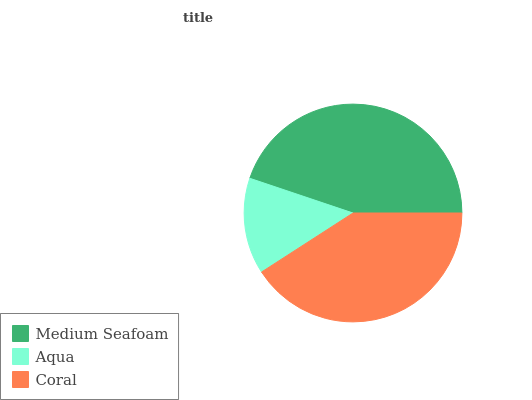Is Aqua the minimum?
Answer yes or no. Yes. Is Medium Seafoam the maximum?
Answer yes or no. Yes. Is Coral the minimum?
Answer yes or no. No. Is Coral the maximum?
Answer yes or no. No. Is Coral greater than Aqua?
Answer yes or no. Yes. Is Aqua less than Coral?
Answer yes or no. Yes. Is Aqua greater than Coral?
Answer yes or no. No. Is Coral less than Aqua?
Answer yes or no. No. Is Coral the high median?
Answer yes or no. Yes. Is Coral the low median?
Answer yes or no. Yes. Is Medium Seafoam the high median?
Answer yes or no. No. Is Medium Seafoam the low median?
Answer yes or no. No. 